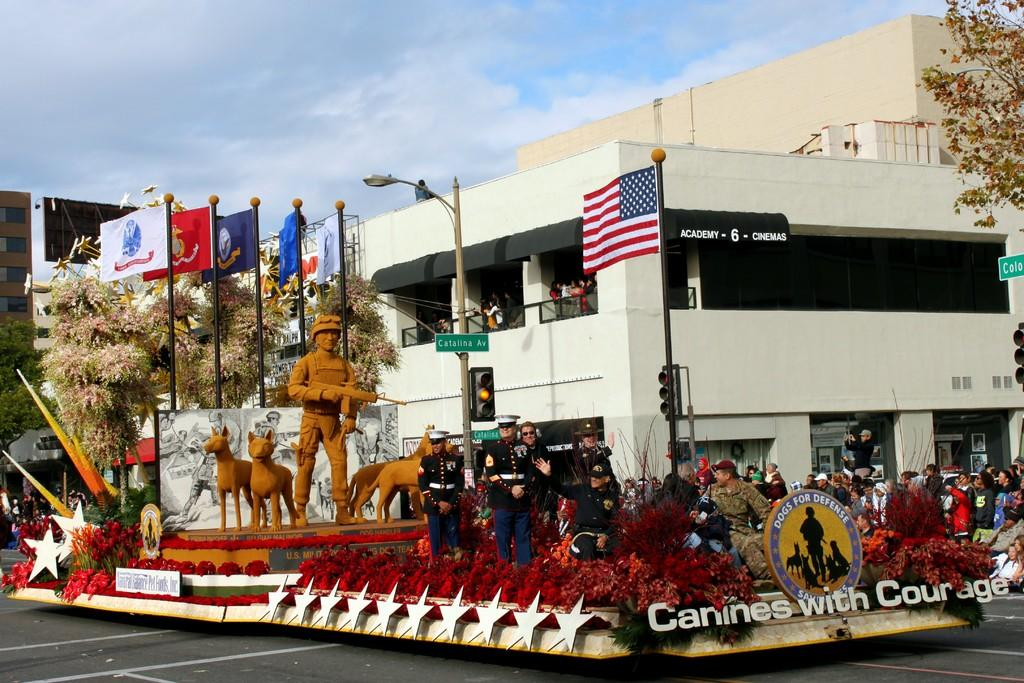<image>
Summarize the visual content of the image. Officers stand outside of a building at a Canines with Courage memorial. 